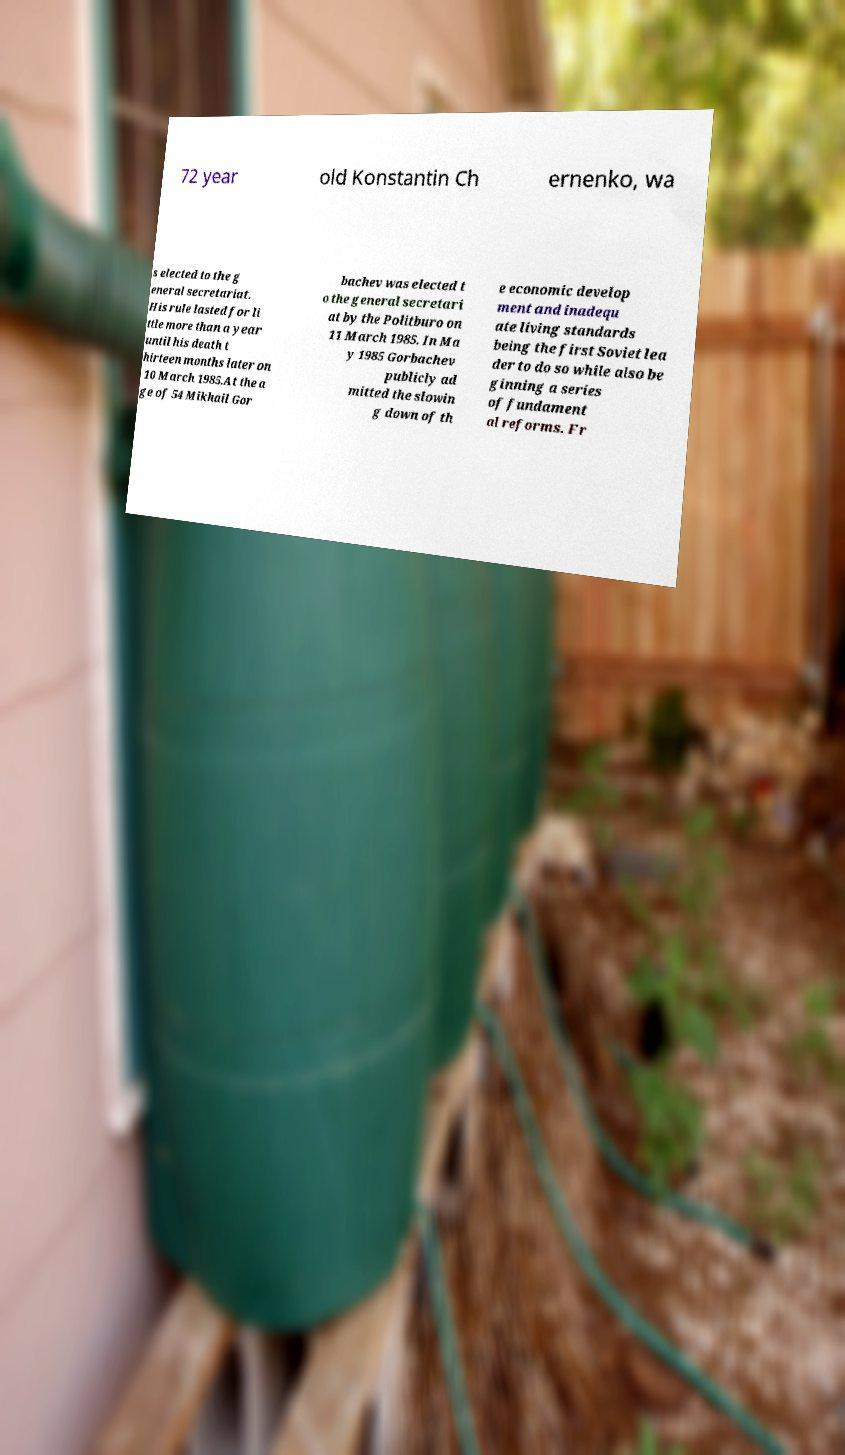Could you extract and type out the text from this image? 72 year old Konstantin Ch ernenko, wa s elected to the g eneral secretariat. His rule lasted for li ttle more than a year until his death t hirteen months later on 10 March 1985.At the a ge of 54 Mikhail Gor bachev was elected t o the general secretari at by the Politburo on 11 March 1985. In Ma y 1985 Gorbachev publicly ad mitted the slowin g down of th e economic develop ment and inadequ ate living standards being the first Soviet lea der to do so while also be ginning a series of fundament al reforms. Fr 